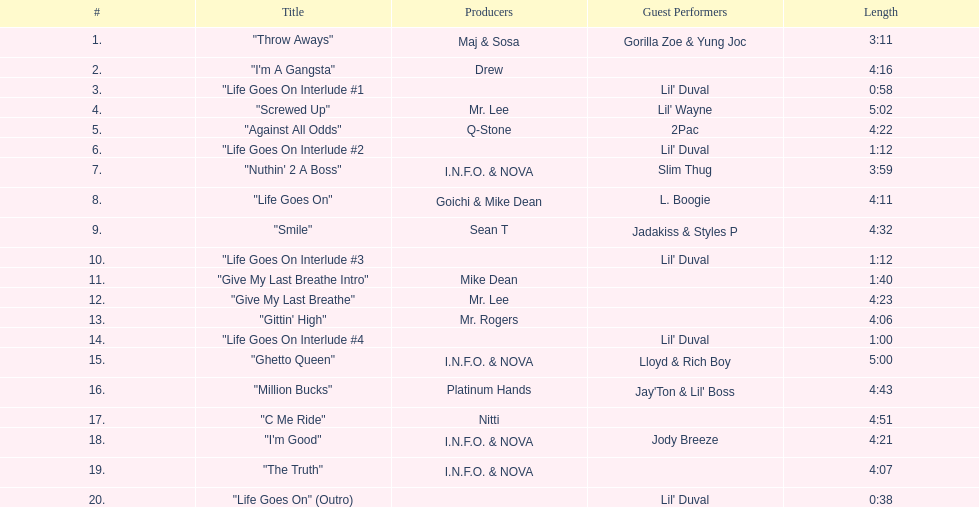Who were the main producers responsible for producing most of the songs on this album? I.N.F.O. & NOVA. 